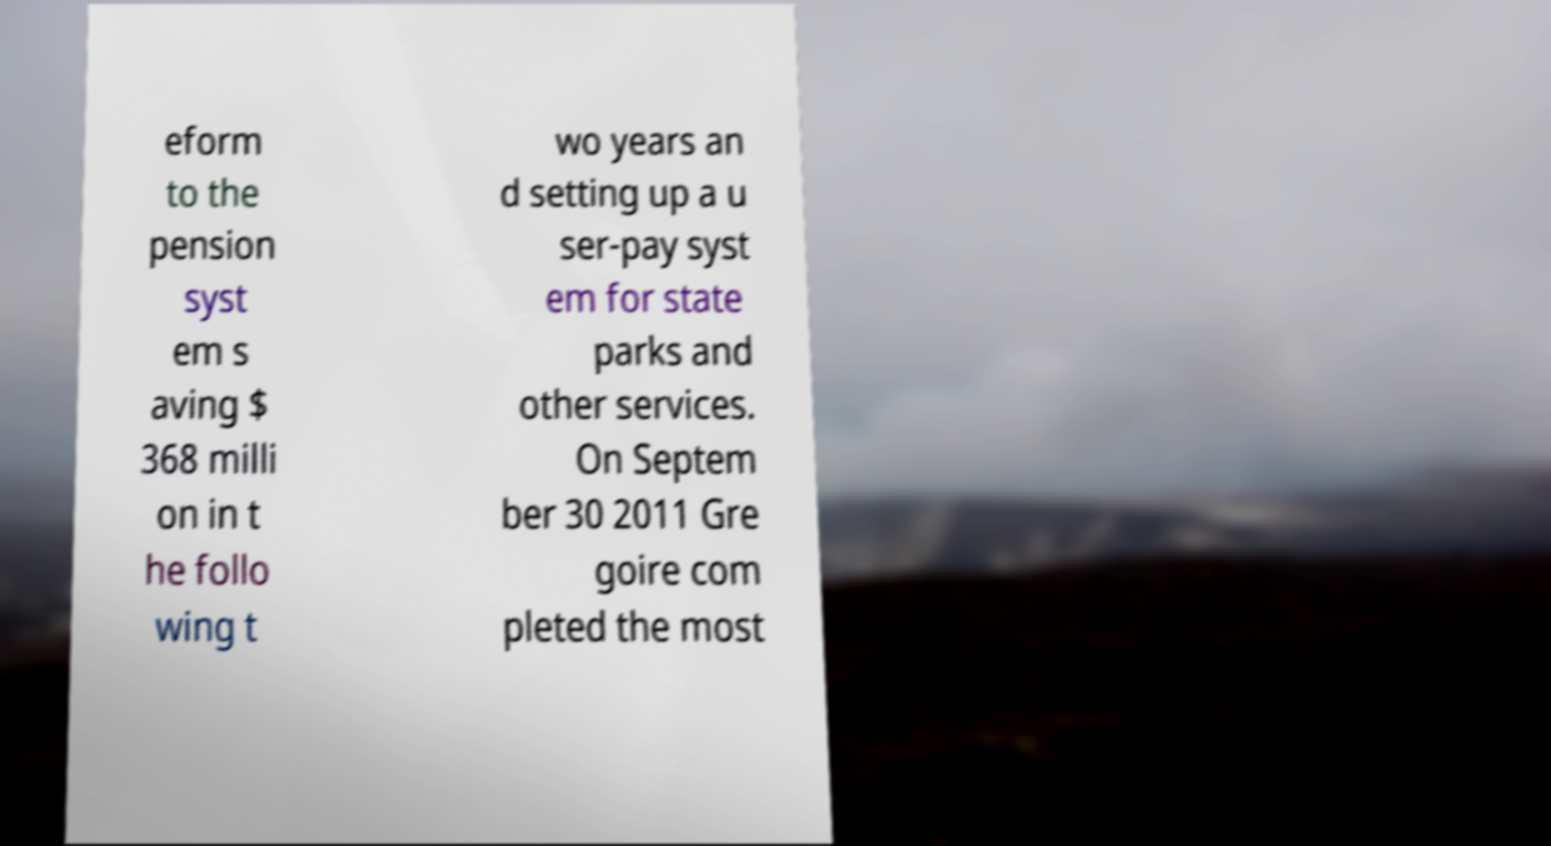Please identify and transcribe the text found in this image. eform to the pension syst em s aving $ 368 milli on in t he follo wing t wo years an d setting up a u ser-pay syst em for state parks and other services. On Septem ber 30 2011 Gre goire com pleted the most 